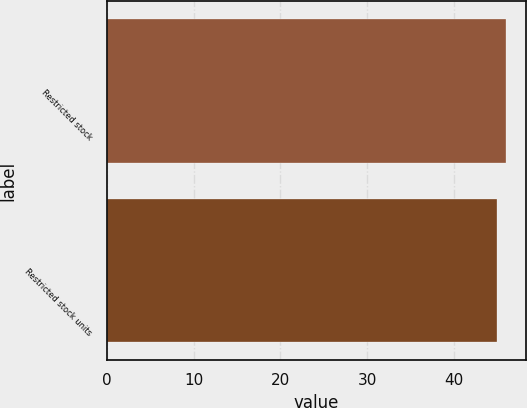Convert chart to OTSL. <chart><loc_0><loc_0><loc_500><loc_500><bar_chart><fcel>Restricted stock<fcel>Restricted stock units<nl><fcel>46<fcel>45<nl></chart> 